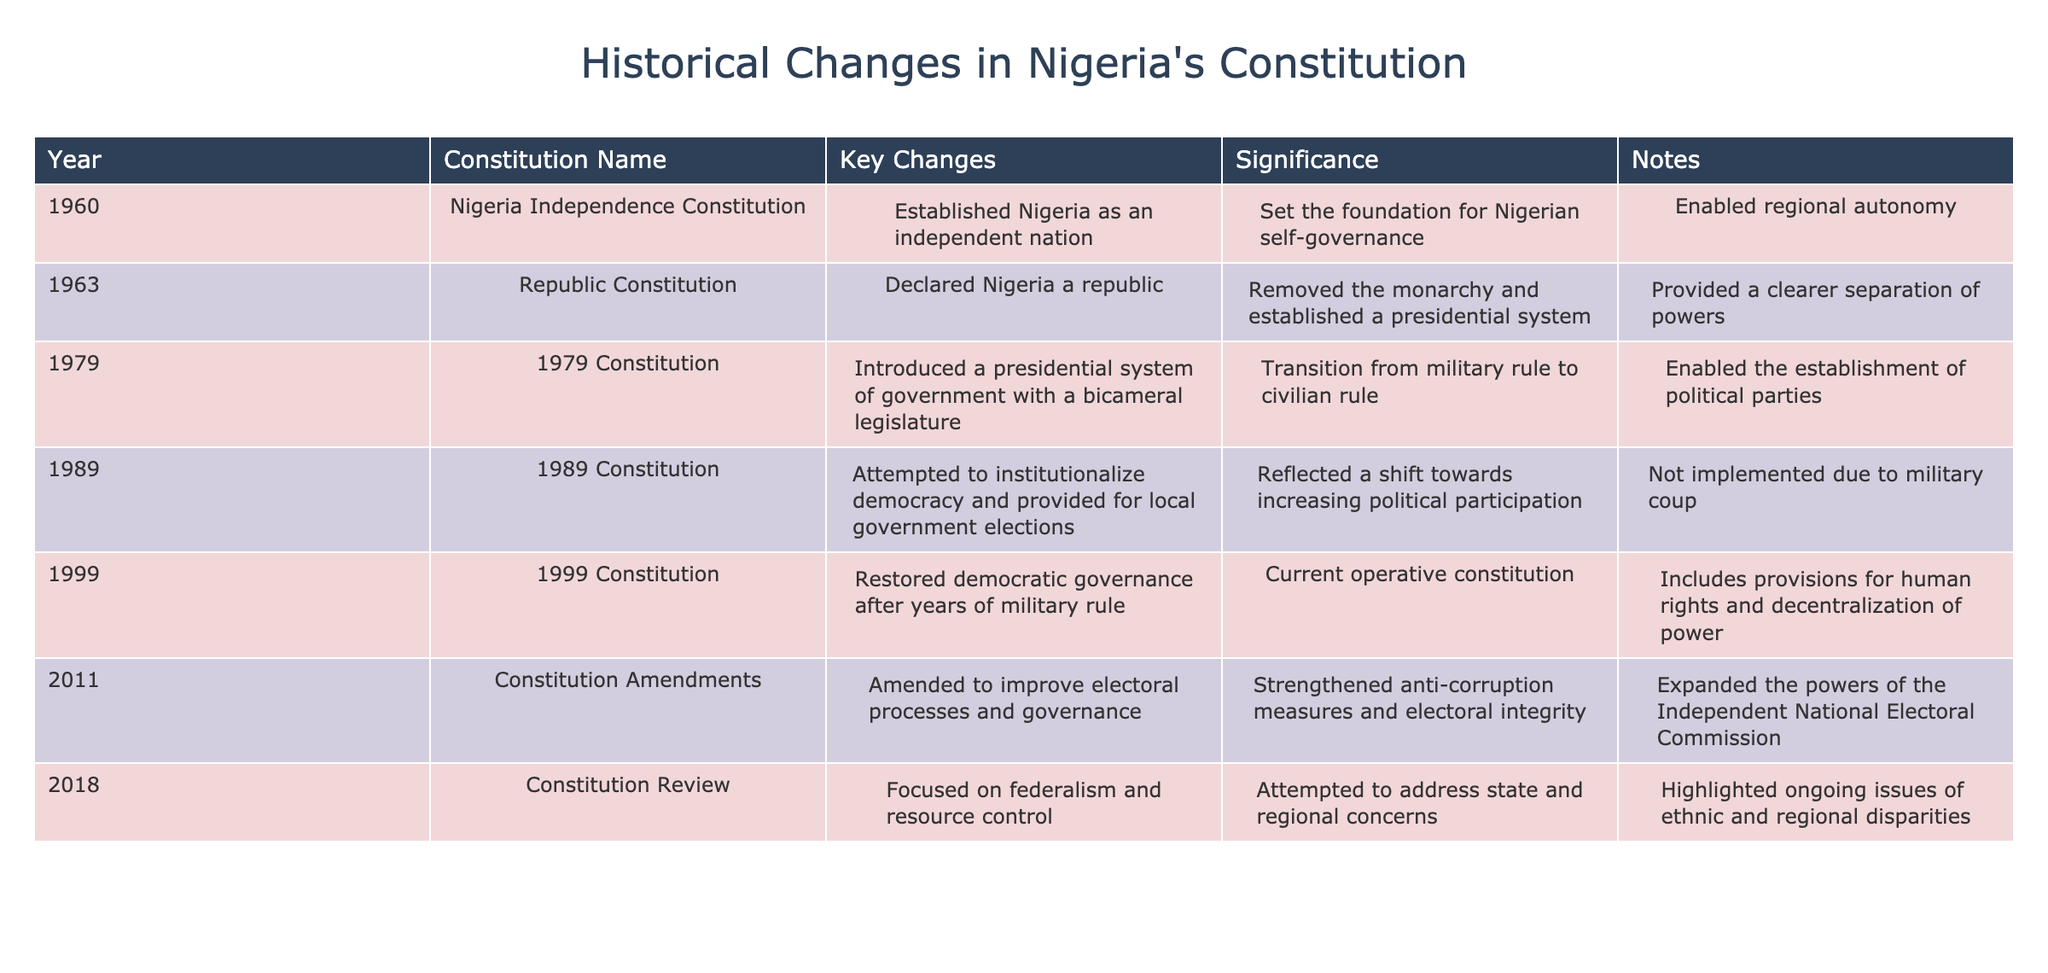What year was the 1979 Constitution introduced? Referring to the table, the "Year" column indicates that the 1979 Constitution was introduced in the year 1979.
Answer: 1979 What key change did the 1989 Constitution attempt to implement? The table shows that the 1989 Constitution attempted to institutionalize democracy and provided for local government elections.
Answer: Institutionalized democracy and local government elections What significance is listed for the Nigeria Independence Constitution? According to the table, the significance is that it set the foundation for Nigerian self-governance.
Answer: Set the foundation for self-governance Which constitution removed the monarchy in Nigeria? The table states that the 1963 Republic Constitution declared Nigeria a republic and removed the monarchy.
Answer: The 1963 Republic Constitution How many constitutions were enacted between 1960 and 1999? The table lists a total of five constitutions from 1960 to 1999: 1960, 1963, 1979, 1989, and 1999, making the number five.
Answer: Five True or False: The 1999 Constitution was implemented after years of military rule. The table clearly states that the 1999 Constitution restored democratic governance after years of military rule, indicating that this statement is true.
Answer: True What was a key feature of the amendments made to the constitution in 2011? The table indicates that the 2011 amendments aimed to improve electoral processes and governance, highlighting strengthening anti-corruption measures.
Answer: Improved electoral processes and governance Compare the significance of the 1979 and 1999 constitutions. What do both emphasize? The 1979 Constitution emphasized the transition from military rule to civilian rule, while the 1999 Constitution focused on restoring democratic governance, so both emphasize a return to democracy.
Answer: Return to democracy List the key changes introduced in the 2018 Constitution Review. The table highlights that the 2018 Constitution Review focused on federalism and resource control, addressing state and regional concerns.
Answer: Federalism and resource control What was a unique aspect of the 1989 Constitution compared to other constitutions listed? The 1989 Constitution is unique because it was not implemented due to a military coup, despite attempts to institutionalize democracy.
Answer: Not implemented due to military coup 